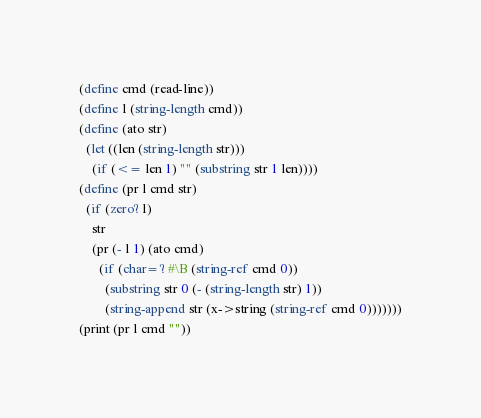<code> <loc_0><loc_0><loc_500><loc_500><_Scheme_>(define cmd (read-line))
(define l (string-length cmd))
(define (ato str)
  (let ((len (string-length str)))
    (if (<= len 1) "" (substring str 1 len))))
(define (pr l cmd str)
  (if (zero? l)
    str
    (pr (- l 1) (ato cmd)
      (if (char=? #\B (string-ref cmd 0))
        (substring str 0 (- (string-length str) 1))
        (string-append str (x->string (string-ref cmd 0)))))))
(print (pr l cmd ""))</code> 